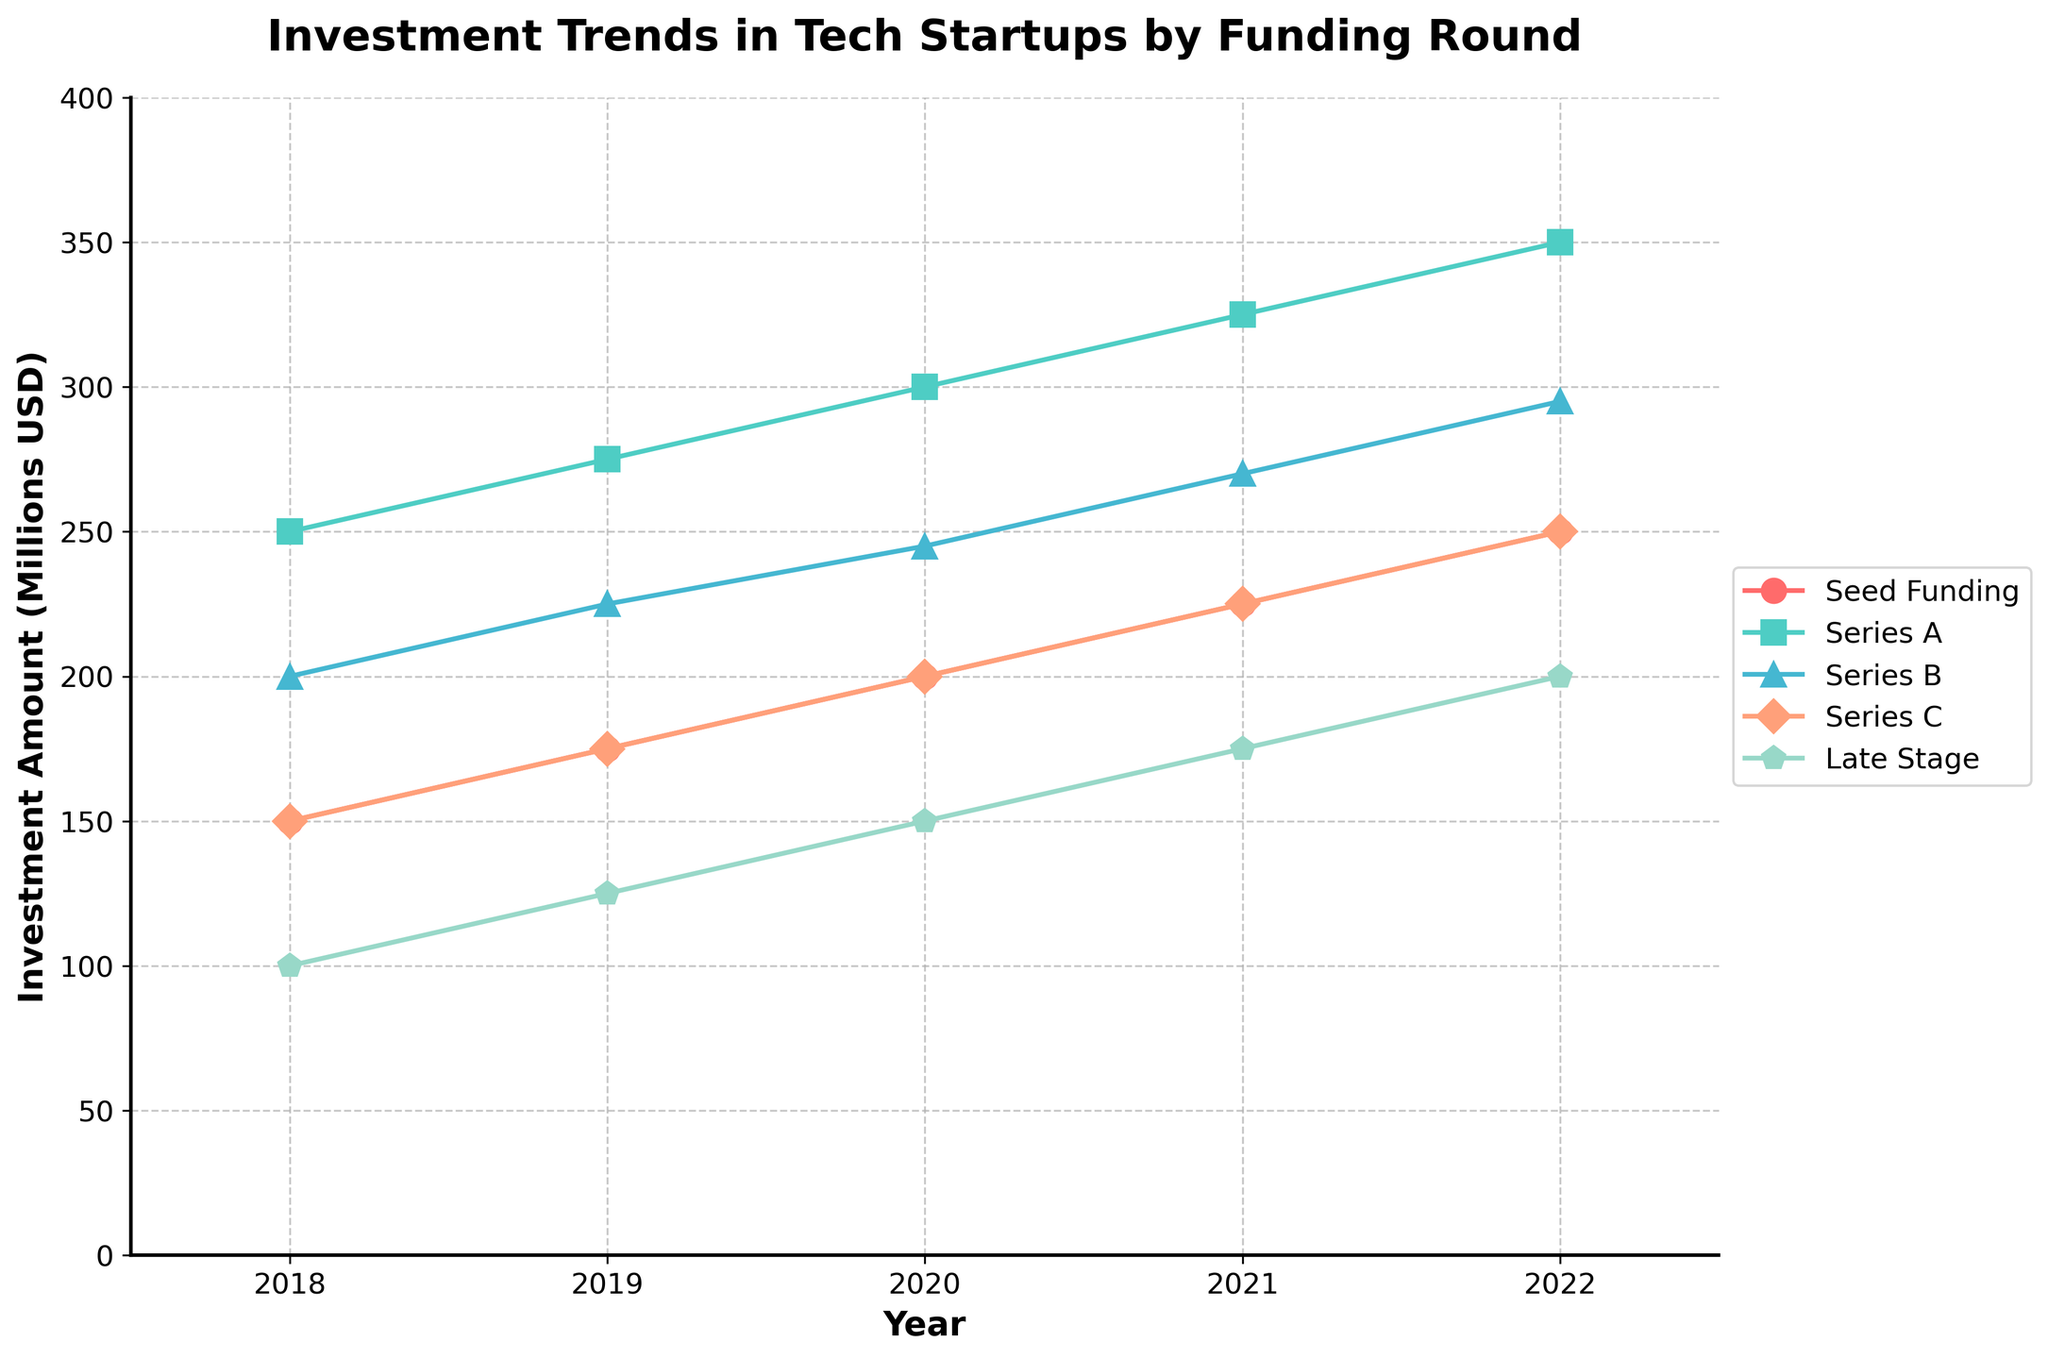what is the title of the chart? The title of the chart is located at the top and reads, "Investment Trends in Tech Startups by Funding Round".
Answer: Investment Trends in Tech Startups by Funding Round Which funding round had the highest investment in 2018? For 2018, compare the investment amounts for each funding round: Seed Funding, Series A, Series B, Series C, and Late Stage. The highest amount is for Series A with 250 million USD.
Answer: Series A How did Late Stage funding change from 2020 to 2022? Observe the trend lines for Late Stage funding from 2020 to 2022. Late Stage funding increased from 150 million USD in 2020 to 200 million USD in 2022, an increase of 50 million USD.
Answer: Increased by 50 million USD What was the total investment amount across all funding rounds in 2021? Sum the investments across all funding rounds for 2021: 225 million USD (Seed Funding) + 325 million USD (Series A) + 270 million USD (Series B) + 225 million USD (Series C) + 175 million USD (Late Stage) = 1220 million USD.
Answer: 1220 million USD Which funding round shows the most consistent increase in investment over the years? Compare the trend lines of all funding rounds. Series A shows the most consistent increase from 250 million USD in 2018 to 350 million USD in 2022, showing consistent yearly growth.
Answer: Series A How does the 2022 Series B funding compare to the 2019 Series B funding? Compare the Series B funding amounts: 295 million USD in 2022 and 225 million USD in 2019. The 2022 funding is higher than the 2019 funding by 70 million USD.
Answer: 2022 is higher by 70 million USD What's the average investment amount for Seed Funding from 2018 to 2022? Sum the Seed Funding amounts over the years and divide by the number of years: (150 + 175 + 200 + 225 + 250) / 5 = 200 million USD.
Answer: 200 million USD Which funding round had the smallest growth between 2018 and 2022? Calculate the growth for each funding round from 2018 to 2022 and find the smallest: Seed Funding (250 - 150 = 100), Series A (350 - 250 = 100), Series B (295 - 200 = 95), Series C (250 - 150 = 100), Late Stage (200 - 100 = 100). Series B had the smallest growth.
Answer: Series B By how much did Series C funding increase from 2018 to 2021? Find the Series C funding amounts for 2018 and 2021 and calculate the increase: 225 million USD in 2021 - 150 million USD in 2018 = 75 million USD.
Answer: 75 million USD Which two years had the highest total investments combined? Calculate the total investments for each year and find the two years with the highest sums: 2018 (850) + 2019 (975) + 2020 (1095) + 2021 (1220) + 2022 (1345). The highest sums are from 2021 and 2022.
Answer: 2021 and 2022 